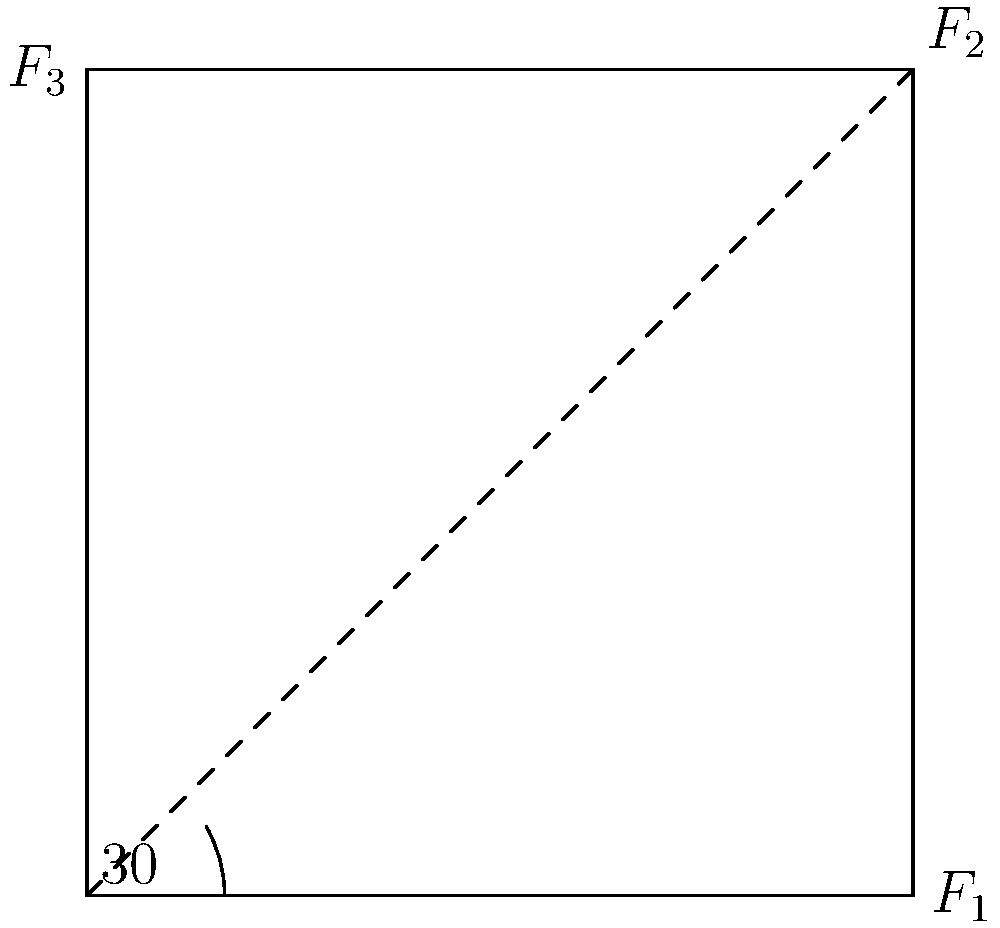In orthodontic treatment, three forces are applied to a tooth by braces: $F_1 = 2$ N horizontally, $F_2 = 3$ N at a 30° angle from the horizontal, and $F_3 = 2.5$ N vertically. Calculate the magnitude of the resultant force vector acting on the tooth. To find the magnitude of the resultant force vector, we need to follow these steps:

1. Decompose $F_2$ into its horizontal and vertical components:
   $F_{2x} = F_2 \cos(30°) = 3 \cos(30°) = 3 \cdot \frac{\sqrt{3}}{2} = 2.60$ N
   $F_{2y} = F_2 \sin(30°) = 3 \sin(30°) = 3 \cdot \frac{1}{2} = 1.50$ N

2. Sum up all horizontal components:
   $F_x = F_1 + F_{2x} = 2 + 2.60 = 4.60$ N

3. Sum up all vertical components:
   $F_y = F_{2y} + F_3 = 1.50 + 2.5 = 4.00$ N

4. Calculate the magnitude of the resultant force using the Pythagorean theorem:
   $F_{resultant} = \sqrt{F_x^2 + F_y^2} = \sqrt{(4.60)^2 + (4.00)^2} = \sqrt{21.16 + 16.00} = \sqrt{37.16} = 6.10$ N

Therefore, the magnitude of the resultant force vector acting on the tooth is approximately 6.10 N.
Answer: 6.10 N 